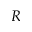Convert formula to latex. <formula><loc_0><loc_0><loc_500><loc_500>R</formula> 